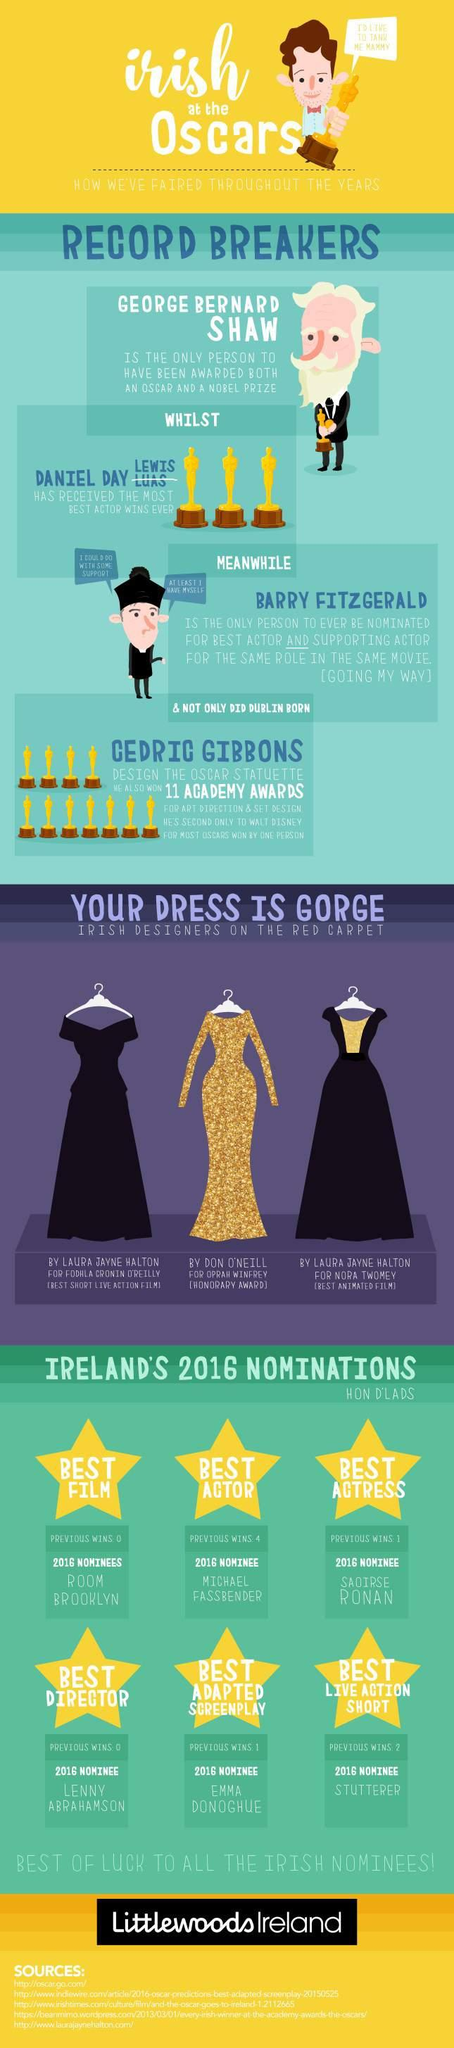Specify some key components in this picture. There are five sources listed at the bottom. 